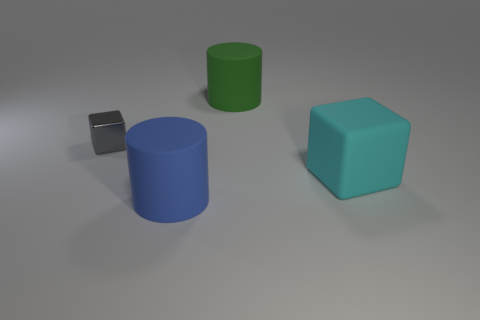Add 4 gray balls. How many objects exist? 8 Add 1 brown rubber things. How many brown rubber things exist? 1 Subtract 0 gray cylinders. How many objects are left? 4 Subtract all small blue cylinders. Subtract all gray blocks. How many objects are left? 3 Add 4 green cylinders. How many green cylinders are left? 5 